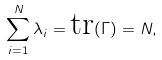Convert formula to latex. <formula><loc_0><loc_0><loc_500><loc_500>\sum _ { i = 1 } ^ { N } \lambda _ { i } = \text {tr} ( \Gamma ) = N ,</formula> 